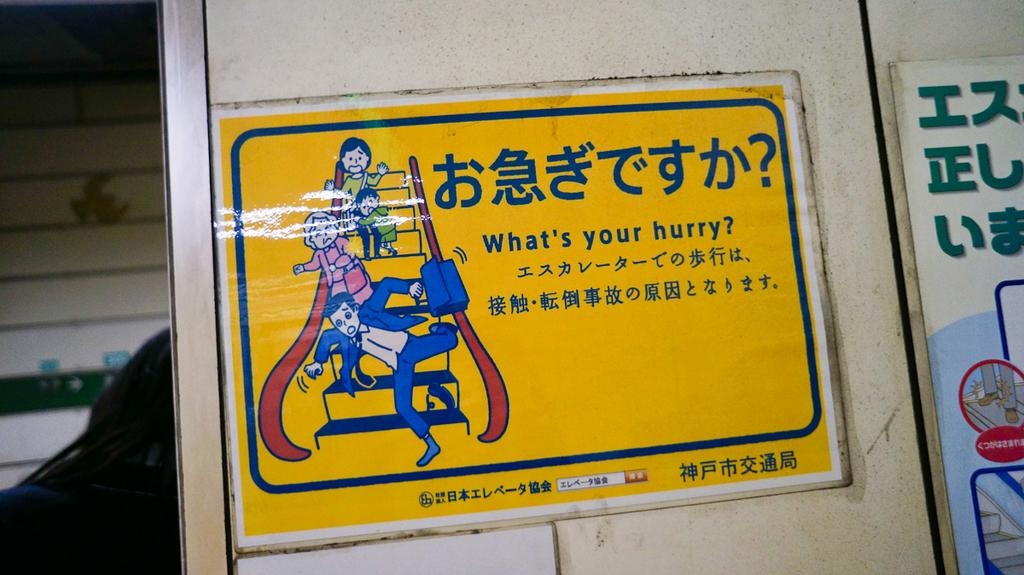<image>
Render a clear and concise summary of the photo. A yellow sticker showing a man falling down a flight of stairs asks what's your hurry. 